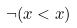Convert formula to latex. <formula><loc_0><loc_0><loc_500><loc_500>\neg ( x < x )</formula> 